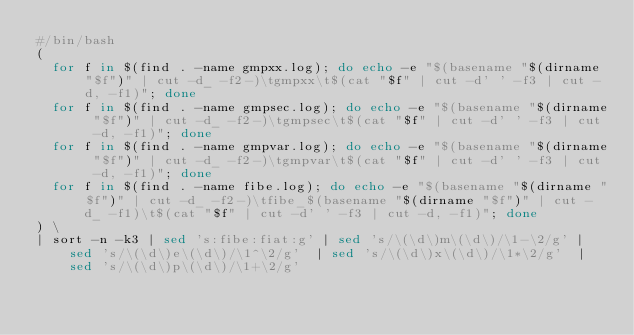Convert code to text. <code><loc_0><loc_0><loc_500><loc_500><_Bash_>#/bin/bash
( 
  for f in $(find . -name gmpxx.log); do echo -e "$(basename "$(dirname "$f")" | cut -d_ -f2-)\tgmpxx\t$(cat "$f" | cut -d' ' -f3 | cut -d, -f1)"; done
  for f in $(find . -name gmpsec.log); do echo -e "$(basename "$(dirname "$f")" | cut -d_ -f2-)\tgmpsec\t$(cat "$f" | cut -d' ' -f3 | cut -d, -f1)"; done
  for f in $(find . -name gmpvar.log); do echo -e "$(basename "$(dirname "$f")" | cut -d_ -f2-)\tgmpvar\t$(cat "$f" | cut -d' ' -f3 | cut -d, -f1)"; done
  for f in $(find . -name fibe.log); do echo -e "$(basename "$(dirname "$f")" | cut -d_ -f2-)\tfibe_$(basename "$(dirname "$f")" | cut -d_ -f1)\t$(cat "$f" | cut -d' ' -f3 | cut -d, -f1)"; done
) \
| sort -n -k3 | sed 's:fibe:fiat:g' | sed 's/\(\d\)m\(\d\)/\1-\2/g' | sed 's/\(\d\)e\(\d\)/\1^\2/g'  | sed 's/\(\d\)x\(\d\)/\1*\2/g'  | sed 's/\(\d\)p\(\d\)/\1+\2/g' 
</code> 